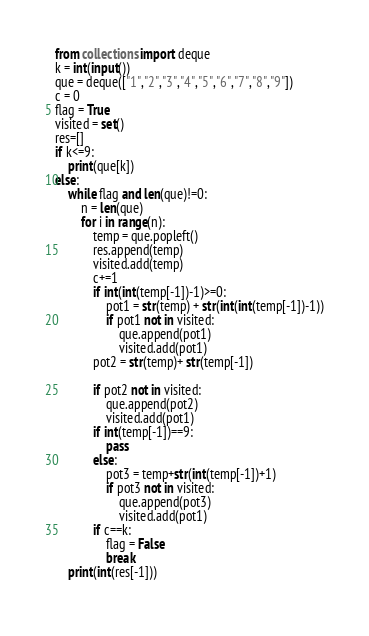<code> <loc_0><loc_0><loc_500><loc_500><_Python_>from collections import deque
k = int(input())
que = deque(["1","2","3","4","5","6","7","8","9"])
c = 0
flag = True
visited = set()
res=[]
if k<=9:
    print(que[k])
else:
    while flag and len(que)!=0:
        n = len(que)
        for i in range(n):
            temp = que.popleft()
            res.append(temp)
            visited.add(temp)
            c+=1
            if int(int(temp[-1])-1)>=0:
                pot1 = str(temp) + str(int(int(temp[-1])-1))
                if pot1 not in visited:
                    que.append(pot1)
                    visited.add(pot1)
            pot2 = str(temp)+ str(temp[-1])
            
            if pot2 not in visited:
                que.append(pot2)
                visited.add(pot1)
            if int(temp[-1])==9:
                pass
            else:
                pot3 = temp+str(int(temp[-1])+1)
                if pot3 not in visited:
                    que.append(pot3)
                    visited.add(pot1)
            if c==k:
                flag = False
                break
    print(int(res[-1]))
            
</code> 